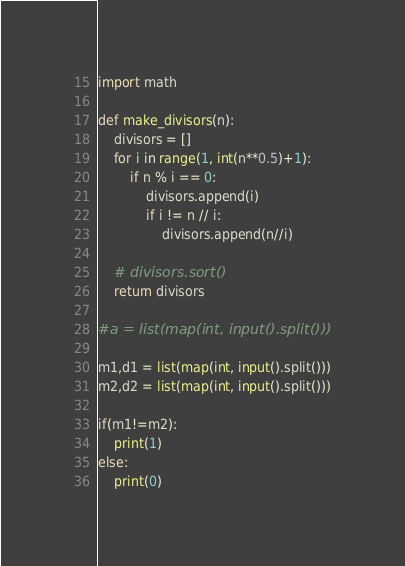Convert code to text. <code><loc_0><loc_0><loc_500><loc_500><_Python_>import math

def make_divisors(n):
    divisors = []
    for i in range(1, int(n**0.5)+1):
        if n % i == 0:
            divisors.append(i)
            if i != n // i:
                divisors.append(n//i)

    # divisors.sort()
    return divisors

#a = list(map(int, input().split()))

m1,d1 = list(map(int, input().split()))
m2,d2 = list(map(int, input().split()))

if(m1!=m2):
    print(1)
else:
    print(0)</code> 